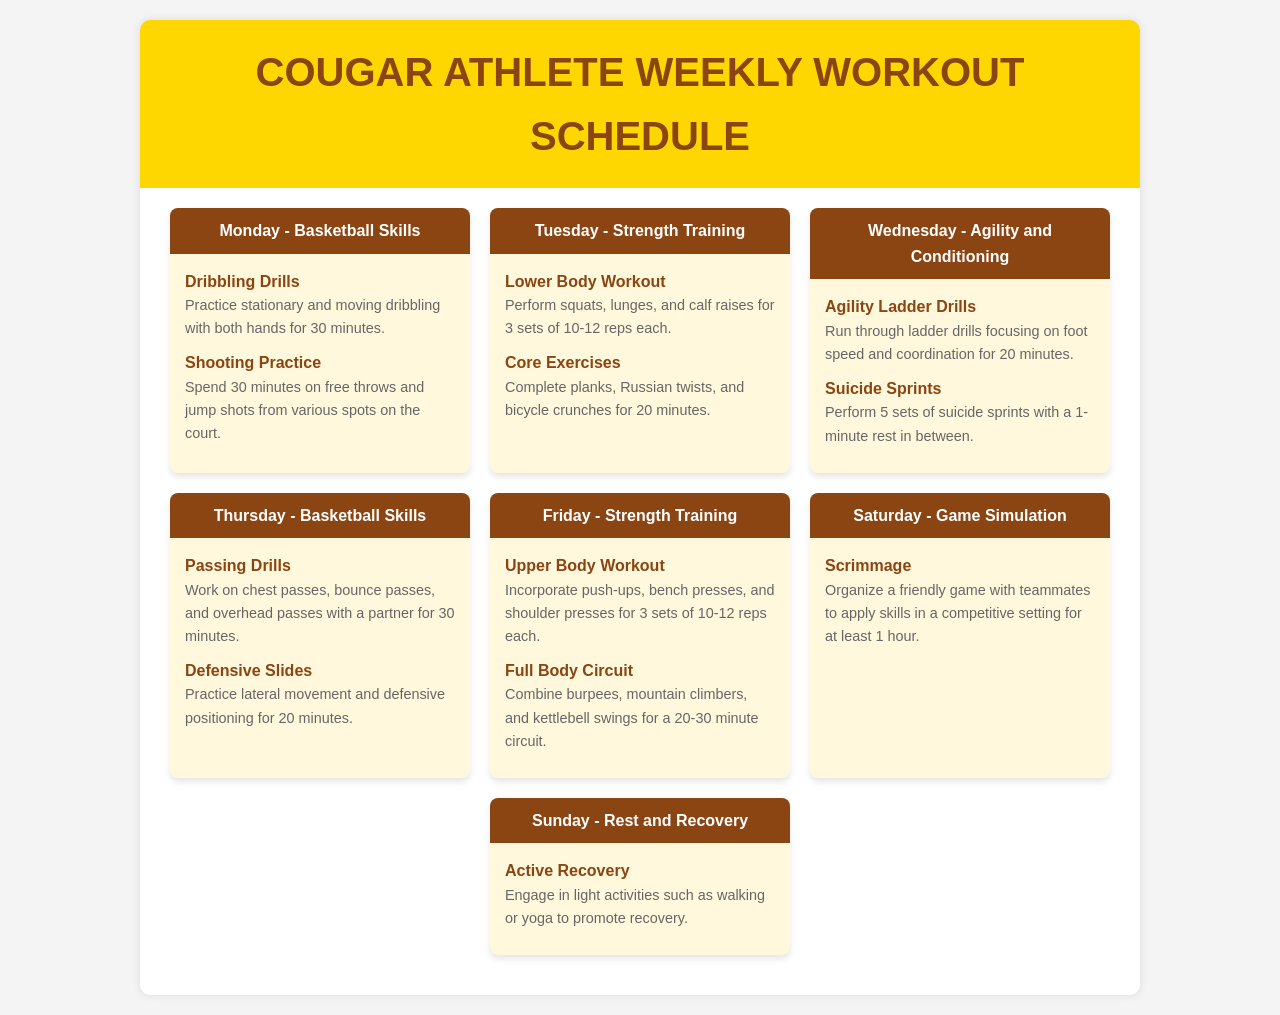What activities are scheduled for Monday? Monday includes Dribbling Drills and Shooting Practice, focusing on basketball skills.
Answer: Dribbling Drills, Shooting Practice How many sets are recommended for the Lower Body Workout? The exercise schedule suggests performing 3 sets of 10-12 reps for the Lower Body Workout.
Answer: 3 sets What is the focus of Wednesday's training? Wednesday's training is dedicated to Agility and Conditioning, aiming to improve speed and endurance.
Answer: Agility and Conditioning What type of workout is scheduled for Thursday? Thursday's schedule includes Basketball Skills activities like Passing Drills and Defensive Slides.
Answer: Basketball Skills How long should the scrimmage last on Saturday? The recommended duration for the scrimmage on Saturday is at least 1 hour.
Answer: 1 hour What is the primary activity for Sunday? The main activity on Sunday is Active Recovery, which promotes rest and recuperation.
Answer: Active Recovery Which day includes Core Exercises? Core Exercises are part of the Strength Training activities on Tuesday.
Answer: Tuesday How many minutes are allocated for Agility Ladder Drills? The schedule allocates 20 minutes for running through Agility Ladder Drills.
Answer: 20 minutes What type of drills are included for Tuesday's workout? Tuesday includes strength-focused activities like Lower Body Workout and Core Exercises.
Answer: Strength Training 